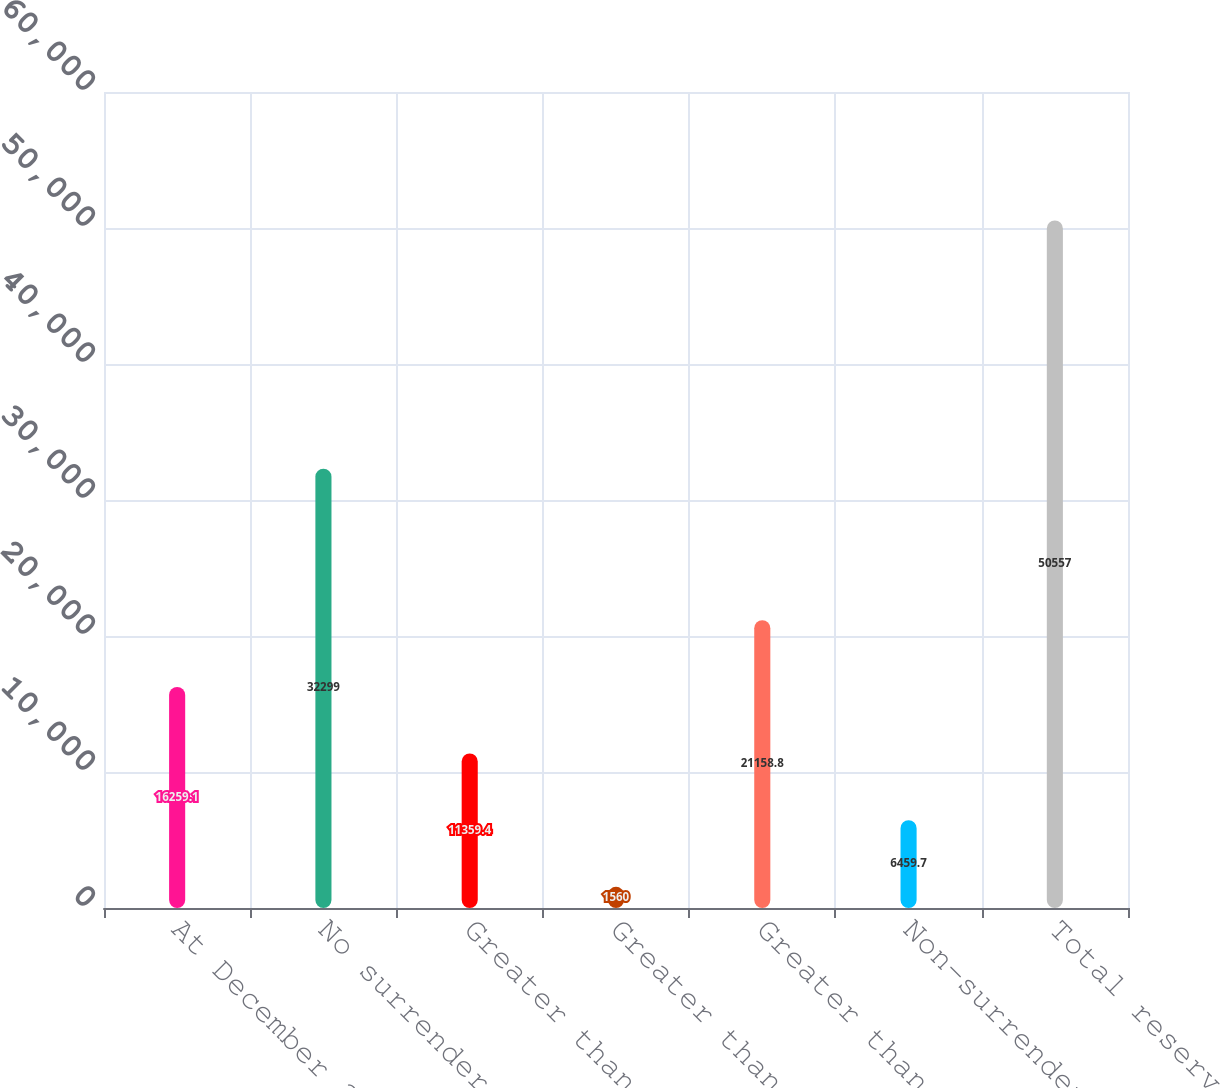Convert chart. <chart><loc_0><loc_0><loc_500><loc_500><bar_chart><fcel>At December 31<fcel>No surrender charge<fcel>Greater than 0 - 2<fcel>Greater than 2 - 4<fcel>Greater than 4<fcel>Non-surrenderable<fcel>Total reserves<nl><fcel>16259.1<fcel>32299<fcel>11359.4<fcel>1560<fcel>21158.8<fcel>6459.7<fcel>50557<nl></chart> 